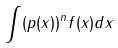<formula> <loc_0><loc_0><loc_500><loc_500>\int ( p ( x ) ) ^ { n } f ( x ) d x</formula> 